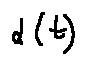Convert formula to latex. <formula><loc_0><loc_0><loc_500><loc_500>\alpha ( t )</formula> 